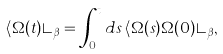Convert formula to latex. <formula><loc_0><loc_0><loc_500><loc_500>\langle \Omega ( t ) \rangle _ { \beta } = \int _ { 0 } ^ { t } d s \, \langle \Omega ( s ) \Omega ( 0 ) \rangle _ { \beta } ,</formula> 